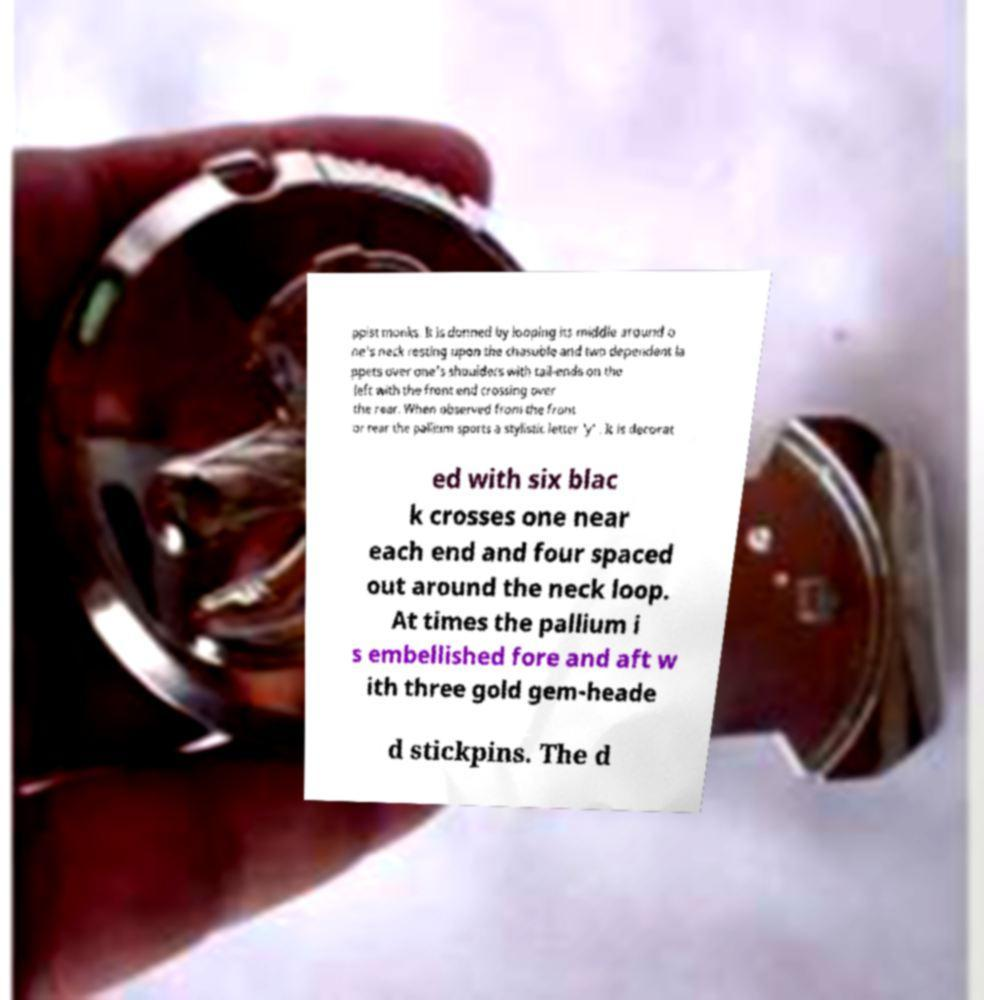Can you accurately transcribe the text from the provided image for me? ppist monks. It is donned by looping its middle around o ne's neck resting upon the chasuble and two dependent la ppets over one's shoulders with tail-ends on the left with the front end crossing over the rear. When observed from the front or rear the pallium sports a stylistic letter 'y' . It is decorat ed with six blac k crosses one near each end and four spaced out around the neck loop. At times the pallium i s embellished fore and aft w ith three gold gem-heade d stickpins. The d 